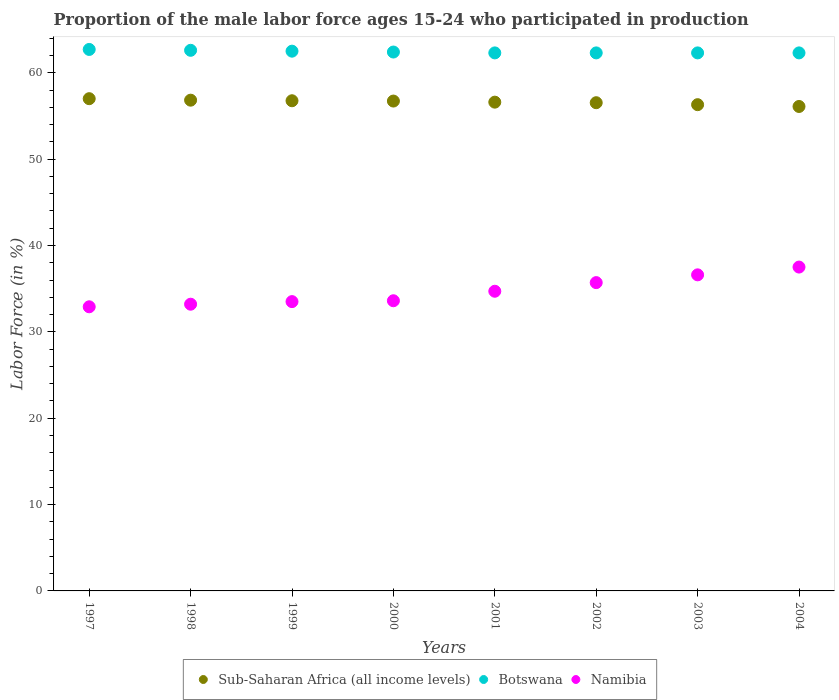What is the proportion of the male labor force who participated in production in Sub-Saharan Africa (all income levels) in 1999?
Ensure brevity in your answer.  56.76. Across all years, what is the maximum proportion of the male labor force who participated in production in Namibia?
Keep it short and to the point. 37.5. Across all years, what is the minimum proportion of the male labor force who participated in production in Botswana?
Make the answer very short. 62.3. In which year was the proportion of the male labor force who participated in production in Namibia maximum?
Make the answer very short. 2004. In which year was the proportion of the male labor force who participated in production in Botswana minimum?
Your answer should be compact. 2001. What is the total proportion of the male labor force who participated in production in Namibia in the graph?
Make the answer very short. 277.7. What is the difference between the proportion of the male labor force who participated in production in Botswana in 1998 and that in 2001?
Make the answer very short. 0.3. What is the difference between the proportion of the male labor force who participated in production in Sub-Saharan Africa (all income levels) in 2003 and the proportion of the male labor force who participated in production in Namibia in 1997?
Provide a succinct answer. 23.4. What is the average proportion of the male labor force who participated in production in Botswana per year?
Your answer should be compact. 62.42. In the year 2000, what is the difference between the proportion of the male labor force who participated in production in Sub-Saharan Africa (all income levels) and proportion of the male labor force who participated in production in Namibia?
Offer a terse response. 23.12. In how many years, is the proportion of the male labor force who participated in production in Namibia greater than 32 %?
Offer a terse response. 8. What is the ratio of the proportion of the male labor force who participated in production in Botswana in 1997 to that in 1999?
Offer a terse response. 1. What is the difference between the highest and the second highest proportion of the male labor force who participated in production in Botswana?
Make the answer very short. 0.1. What is the difference between the highest and the lowest proportion of the male labor force who participated in production in Namibia?
Offer a terse response. 4.6. In how many years, is the proportion of the male labor force who participated in production in Namibia greater than the average proportion of the male labor force who participated in production in Namibia taken over all years?
Your answer should be compact. 3. Is it the case that in every year, the sum of the proportion of the male labor force who participated in production in Sub-Saharan Africa (all income levels) and proportion of the male labor force who participated in production in Namibia  is greater than the proportion of the male labor force who participated in production in Botswana?
Your answer should be compact. Yes. Is the proportion of the male labor force who participated in production in Botswana strictly less than the proportion of the male labor force who participated in production in Sub-Saharan Africa (all income levels) over the years?
Your answer should be very brief. No. How many years are there in the graph?
Keep it short and to the point. 8. What is the difference between two consecutive major ticks on the Y-axis?
Offer a very short reply. 10. Does the graph contain any zero values?
Your response must be concise. No. Does the graph contain grids?
Offer a very short reply. No. Where does the legend appear in the graph?
Make the answer very short. Bottom center. How are the legend labels stacked?
Your answer should be compact. Horizontal. What is the title of the graph?
Offer a terse response. Proportion of the male labor force ages 15-24 who participated in production. What is the label or title of the Y-axis?
Provide a succinct answer. Labor Force (in %). What is the Labor Force (in %) of Sub-Saharan Africa (all income levels) in 1997?
Make the answer very short. 57. What is the Labor Force (in %) in Botswana in 1997?
Your answer should be very brief. 62.7. What is the Labor Force (in %) of Namibia in 1997?
Keep it short and to the point. 32.9. What is the Labor Force (in %) in Sub-Saharan Africa (all income levels) in 1998?
Make the answer very short. 56.83. What is the Labor Force (in %) in Botswana in 1998?
Offer a terse response. 62.6. What is the Labor Force (in %) in Namibia in 1998?
Your response must be concise. 33.2. What is the Labor Force (in %) in Sub-Saharan Africa (all income levels) in 1999?
Give a very brief answer. 56.76. What is the Labor Force (in %) of Botswana in 1999?
Your response must be concise. 62.5. What is the Labor Force (in %) of Namibia in 1999?
Offer a very short reply. 33.5. What is the Labor Force (in %) in Sub-Saharan Africa (all income levels) in 2000?
Keep it short and to the point. 56.72. What is the Labor Force (in %) of Botswana in 2000?
Provide a succinct answer. 62.4. What is the Labor Force (in %) of Namibia in 2000?
Make the answer very short. 33.6. What is the Labor Force (in %) in Sub-Saharan Africa (all income levels) in 2001?
Your answer should be very brief. 56.6. What is the Labor Force (in %) in Botswana in 2001?
Your response must be concise. 62.3. What is the Labor Force (in %) of Namibia in 2001?
Make the answer very short. 34.7. What is the Labor Force (in %) of Sub-Saharan Africa (all income levels) in 2002?
Provide a succinct answer. 56.53. What is the Labor Force (in %) of Botswana in 2002?
Your response must be concise. 62.3. What is the Labor Force (in %) of Namibia in 2002?
Provide a short and direct response. 35.7. What is the Labor Force (in %) of Sub-Saharan Africa (all income levels) in 2003?
Give a very brief answer. 56.3. What is the Labor Force (in %) of Botswana in 2003?
Make the answer very short. 62.3. What is the Labor Force (in %) of Namibia in 2003?
Provide a short and direct response. 36.6. What is the Labor Force (in %) in Sub-Saharan Africa (all income levels) in 2004?
Ensure brevity in your answer.  56.1. What is the Labor Force (in %) of Botswana in 2004?
Make the answer very short. 62.3. What is the Labor Force (in %) of Namibia in 2004?
Offer a terse response. 37.5. Across all years, what is the maximum Labor Force (in %) in Sub-Saharan Africa (all income levels)?
Provide a short and direct response. 57. Across all years, what is the maximum Labor Force (in %) of Botswana?
Keep it short and to the point. 62.7. Across all years, what is the maximum Labor Force (in %) of Namibia?
Your answer should be very brief. 37.5. Across all years, what is the minimum Labor Force (in %) of Sub-Saharan Africa (all income levels)?
Your answer should be compact. 56.1. Across all years, what is the minimum Labor Force (in %) in Botswana?
Your answer should be compact. 62.3. Across all years, what is the minimum Labor Force (in %) of Namibia?
Your response must be concise. 32.9. What is the total Labor Force (in %) in Sub-Saharan Africa (all income levels) in the graph?
Make the answer very short. 452.83. What is the total Labor Force (in %) in Botswana in the graph?
Your answer should be very brief. 499.4. What is the total Labor Force (in %) in Namibia in the graph?
Your answer should be compact. 277.7. What is the difference between the Labor Force (in %) of Sub-Saharan Africa (all income levels) in 1997 and that in 1998?
Your response must be concise. 0.17. What is the difference between the Labor Force (in %) of Namibia in 1997 and that in 1998?
Provide a succinct answer. -0.3. What is the difference between the Labor Force (in %) in Sub-Saharan Africa (all income levels) in 1997 and that in 1999?
Provide a succinct answer. 0.24. What is the difference between the Labor Force (in %) in Botswana in 1997 and that in 1999?
Offer a terse response. 0.2. What is the difference between the Labor Force (in %) in Sub-Saharan Africa (all income levels) in 1997 and that in 2000?
Provide a succinct answer. 0.28. What is the difference between the Labor Force (in %) of Botswana in 1997 and that in 2000?
Your response must be concise. 0.3. What is the difference between the Labor Force (in %) of Sub-Saharan Africa (all income levels) in 1997 and that in 2001?
Keep it short and to the point. 0.4. What is the difference between the Labor Force (in %) in Botswana in 1997 and that in 2001?
Your response must be concise. 0.4. What is the difference between the Labor Force (in %) of Sub-Saharan Africa (all income levels) in 1997 and that in 2002?
Your answer should be compact. 0.47. What is the difference between the Labor Force (in %) of Botswana in 1997 and that in 2002?
Your answer should be very brief. 0.4. What is the difference between the Labor Force (in %) in Namibia in 1997 and that in 2002?
Provide a succinct answer. -2.8. What is the difference between the Labor Force (in %) in Sub-Saharan Africa (all income levels) in 1997 and that in 2003?
Your answer should be compact. 0.69. What is the difference between the Labor Force (in %) in Botswana in 1997 and that in 2003?
Give a very brief answer. 0.4. What is the difference between the Labor Force (in %) in Namibia in 1997 and that in 2003?
Your answer should be compact. -3.7. What is the difference between the Labor Force (in %) in Sub-Saharan Africa (all income levels) in 1997 and that in 2004?
Provide a short and direct response. 0.9. What is the difference between the Labor Force (in %) in Botswana in 1997 and that in 2004?
Your answer should be very brief. 0.4. What is the difference between the Labor Force (in %) in Namibia in 1997 and that in 2004?
Offer a very short reply. -4.6. What is the difference between the Labor Force (in %) of Sub-Saharan Africa (all income levels) in 1998 and that in 1999?
Provide a succinct answer. 0.07. What is the difference between the Labor Force (in %) of Sub-Saharan Africa (all income levels) in 1998 and that in 2000?
Keep it short and to the point. 0.1. What is the difference between the Labor Force (in %) of Namibia in 1998 and that in 2000?
Your answer should be compact. -0.4. What is the difference between the Labor Force (in %) of Sub-Saharan Africa (all income levels) in 1998 and that in 2001?
Your answer should be very brief. 0.23. What is the difference between the Labor Force (in %) of Botswana in 1998 and that in 2001?
Your answer should be compact. 0.3. What is the difference between the Labor Force (in %) of Namibia in 1998 and that in 2001?
Your response must be concise. -1.5. What is the difference between the Labor Force (in %) in Sub-Saharan Africa (all income levels) in 1998 and that in 2002?
Ensure brevity in your answer.  0.29. What is the difference between the Labor Force (in %) of Namibia in 1998 and that in 2002?
Keep it short and to the point. -2.5. What is the difference between the Labor Force (in %) of Sub-Saharan Africa (all income levels) in 1998 and that in 2003?
Give a very brief answer. 0.52. What is the difference between the Labor Force (in %) in Namibia in 1998 and that in 2003?
Offer a very short reply. -3.4. What is the difference between the Labor Force (in %) in Sub-Saharan Africa (all income levels) in 1998 and that in 2004?
Keep it short and to the point. 0.73. What is the difference between the Labor Force (in %) of Botswana in 1998 and that in 2004?
Your response must be concise. 0.3. What is the difference between the Labor Force (in %) in Namibia in 1998 and that in 2004?
Your answer should be compact. -4.3. What is the difference between the Labor Force (in %) of Sub-Saharan Africa (all income levels) in 1999 and that in 2000?
Offer a very short reply. 0.04. What is the difference between the Labor Force (in %) of Sub-Saharan Africa (all income levels) in 1999 and that in 2001?
Your answer should be very brief. 0.16. What is the difference between the Labor Force (in %) in Namibia in 1999 and that in 2001?
Your response must be concise. -1.2. What is the difference between the Labor Force (in %) of Sub-Saharan Africa (all income levels) in 1999 and that in 2002?
Give a very brief answer. 0.23. What is the difference between the Labor Force (in %) of Botswana in 1999 and that in 2002?
Your answer should be compact. 0.2. What is the difference between the Labor Force (in %) of Namibia in 1999 and that in 2002?
Your answer should be very brief. -2.2. What is the difference between the Labor Force (in %) in Sub-Saharan Africa (all income levels) in 1999 and that in 2003?
Your answer should be compact. 0.45. What is the difference between the Labor Force (in %) of Namibia in 1999 and that in 2003?
Provide a succinct answer. -3.1. What is the difference between the Labor Force (in %) of Sub-Saharan Africa (all income levels) in 1999 and that in 2004?
Provide a short and direct response. 0.66. What is the difference between the Labor Force (in %) in Botswana in 1999 and that in 2004?
Provide a succinct answer. 0.2. What is the difference between the Labor Force (in %) in Namibia in 1999 and that in 2004?
Give a very brief answer. -4. What is the difference between the Labor Force (in %) of Sub-Saharan Africa (all income levels) in 2000 and that in 2001?
Ensure brevity in your answer.  0.13. What is the difference between the Labor Force (in %) in Namibia in 2000 and that in 2001?
Your answer should be very brief. -1.1. What is the difference between the Labor Force (in %) of Sub-Saharan Africa (all income levels) in 2000 and that in 2002?
Your answer should be very brief. 0.19. What is the difference between the Labor Force (in %) in Namibia in 2000 and that in 2002?
Your answer should be compact. -2.1. What is the difference between the Labor Force (in %) in Sub-Saharan Africa (all income levels) in 2000 and that in 2003?
Offer a very short reply. 0.42. What is the difference between the Labor Force (in %) in Botswana in 2000 and that in 2003?
Provide a short and direct response. 0.1. What is the difference between the Labor Force (in %) of Namibia in 2000 and that in 2003?
Provide a succinct answer. -3. What is the difference between the Labor Force (in %) of Sub-Saharan Africa (all income levels) in 2000 and that in 2004?
Your answer should be very brief. 0.63. What is the difference between the Labor Force (in %) in Namibia in 2000 and that in 2004?
Provide a succinct answer. -3.9. What is the difference between the Labor Force (in %) of Sub-Saharan Africa (all income levels) in 2001 and that in 2002?
Make the answer very short. 0.06. What is the difference between the Labor Force (in %) in Botswana in 2001 and that in 2002?
Your answer should be very brief. 0. What is the difference between the Labor Force (in %) of Namibia in 2001 and that in 2002?
Make the answer very short. -1. What is the difference between the Labor Force (in %) in Sub-Saharan Africa (all income levels) in 2001 and that in 2003?
Your answer should be compact. 0.29. What is the difference between the Labor Force (in %) of Botswana in 2001 and that in 2003?
Offer a terse response. 0. What is the difference between the Labor Force (in %) of Namibia in 2001 and that in 2003?
Keep it short and to the point. -1.9. What is the difference between the Labor Force (in %) of Sub-Saharan Africa (all income levels) in 2001 and that in 2004?
Ensure brevity in your answer.  0.5. What is the difference between the Labor Force (in %) in Namibia in 2001 and that in 2004?
Offer a very short reply. -2.8. What is the difference between the Labor Force (in %) of Sub-Saharan Africa (all income levels) in 2002 and that in 2003?
Make the answer very short. 0.23. What is the difference between the Labor Force (in %) in Botswana in 2002 and that in 2003?
Provide a short and direct response. 0. What is the difference between the Labor Force (in %) of Sub-Saharan Africa (all income levels) in 2002 and that in 2004?
Ensure brevity in your answer.  0.44. What is the difference between the Labor Force (in %) in Sub-Saharan Africa (all income levels) in 2003 and that in 2004?
Your answer should be compact. 0.21. What is the difference between the Labor Force (in %) of Botswana in 2003 and that in 2004?
Offer a very short reply. 0. What is the difference between the Labor Force (in %) of Namibia in 2003 and that in 2004?
Ensure brevity in your answer.  -0.9. What is the difference between the Labor Force (in %) in Sub-Saharan Africa (all income levels) in 1997 and the Labor Force (in %) in Botswana in 1998?
Your answer should be very brief. -5.6. What is the difference between the Labor Force (in %) of Sub-Saharan Africa (all income levels) in 1997 and the Labor Force (in %) of Namibia in 1998?
Provide a short and direct response. 23.8. What is the difference between the Labor Force (in %) of Botswana in 1997 and the Labor Force (in %) of Namibia in 1998?
Offer a very short reply. 29.5. What is the difference between the Labor Force (in %) in Sub-Saharan Africa (all income levels) in 1997 and the Labor Force (in %) in Botswana in 1999?
Your answer should be very brief. -5.5. What is the difference between the Labor Force (in %) in Sub-Saharan Africa (all income levels) in 1997 and the Labor Force (in %) in Namibia in 1999?
Keep it short and to the point. 23.5. What is the difference between the Labor Force (in %) of Botswana in 1997 and the Labor Force (in %) of Namibia in 1999?
Offer a terse response. 29.2. What is the difference between the Labor Force (in %) of Sub-Saharan Africa (all income levels) in 1997 and the Labor Force (in %) of Botswana in 2000?
Ensure brevity in your answer.  -5.4. What is the difference between the Labor Force (in %) of Sub-Saharan Africa (all income levels) in 1997 and the Labor Force (in %) of Namibia in 2000?
Provide a short and direct response. 23.4. What is the difference between the Labor Force (in %) of Botswana in 1997 and the Labor Force (in %) of Namibia in 2000?
Your answer should be compact. 29.1. What is the difference between the Labor Force (in %) in Sub-Saharan Africa (all income levels) in 1997 and the Labor Force (in %) in Botswana in 2001?
Ensure brevity in your answer.  -5.3. What is the difference between the Labor Force (in %) in Sub-Saharan Africa (all income levels) in 1997 and the Labor Force (in %) in Namibia in 2001?
Offer a terse response. 22.3. What is the difference between the Labor Force (in %) of Botswana in 1997 and the Labor Force (in %) of Namibia in 2001?
Provide a short and direct response. 28. What is the difference between the Labor Force (in %) in Sub-Saharan Africa (all income levels) in 1997 and the Labor Force (in %) in Botswana in 2002?
Ensure brevity in your answer.  -5.3. What is the difference between the Labor Force (in %) of Sub-Saharan Africa (all income levels) in 1997 and the Labor Force (in %) of Namibia in 2002?
Keep it short and to the point. 21.3. What is the difference between the Labor Force (in %) in Botswana in 1997 and the Labor Force (in %) in Namibia in 2002?
Make the answer very short. 27. What is the difference between the Labor Force (in %) of Sub-Saharan Africa (all income levels) in 1997 and the Labor Force (in %) of Botswana in 2003?
Ensure brevity in your answer.  -5.3. What is the difference between the Labor Force (in %) in Sub-Saharan Africa (all income levels) in 1997 and the Labor Force (in %) in Namibia in 2003?
Keep it short and to the point. 20.4. What is the difference between the Labor Force (in %) of Botswana in 1997 and the Labor Force (in %) of Namibia in 2003?
Offer a very short reply. 26.1. What is the difference between the Labor Force (in %) of Sub-Saharan Africa (all income levels) in 1997 and the Labor Force (in %) of Botswana in 2004?
Offer a terse response. -5.3. What is the difference between the Labor Force (in %) of Sub-Saharan Africa (all income levels) in 1997 and the Labor Force (in %) of Namibia in 2004?
Give a very brief answer. 19.5. What is the difference between the Labor Force (in %) in Botswana in 1997 and the Labor Force (in %) in Namibia in 2004?
Offer a very short reply. 25.2. What is the difference between the Labor Force (in %) of Sub-Saharan Africa (all income levels) in 1998 and the Labor Force (in %) of Botswana in 1999?
Your response must be concise. -5.67. What is the difference between the Labor Force (in %) in Sub-Saharan Africa (all income levels) in 1998 and the Labor Force (in %) in Namibia in 1999?
Offer a terse response. 23.33. What is the difference between the Labor Force (in %) of Botswana in 1998 and the Labor Force (in %) of Namibia in 1999?
Offer a very short reply. 29.1. What is the difference between the Labor Force (in %) of Sub-Saharan Africa (all income levels) in 1998 and the Labor Force (in %) of Botswana in 2000?
Provide a short and direct response. -5.57. What is the difference between the Labor Force (in %) of Sub-Saharan Africa (all income levels) in 1998 and the Labor Force (in %) of Namibia in 2000?
Give a very brief answer. 23.23. What is the difference between the Labor Force (in %) in Botswana in 1998 and the Labor Force (in %) in Namibia in 2000?
Provide a succinct answer. 29. What is the difference between the Labor Force (in %) of Sub-Saharan Africa (all income levels) in 1998 and the Labor Force (in %) of Botswana in 2001?
Provide a short and direct response. -5.47. What is the difference between the Labor Force (in %) of Sub-Saharan Africa (all income levels) in 1998 and the Labor Force (in %) of Namibia in 2001?
Give a very brief answer. 22.13. What is the difference between the Labor Force (in %) in Botswana in 1998 and the Labor Force (in %) in Namibia in 2001?
Provide a succinct answer. 27.9. What is the difference between the Labor Force (in %) in Sub-Saharan Africa (all income levels) in 1998 and the Labor Force (in %) in Botswana in 2002?
Offer a terse response. -5.47. What is the difference between the Labor Force (in %) of Sub-Saharan Africa (all income levels) in 1998 and the Labor Force (in %) of Namibia in 2002?
Provide a short and direct response. 21.13. What is the difference between the Labor Force (in %) of Botswana in 1998 and the Labor Force (in %) of Namibia in 2002?
Make the answer very short. 26.9. What is the difference between the Labor Force (in %) in Sub-Saharan Africa (all income levels) in 1998 and the Labor Force (in %) in Botswana in 2003?
Provide a succinct answer. -5.47. What is the difference between the Labor Force (in %) in Sub-Saharan Africa (all income levels) in 1998 and the Labor Force (in %) in Namibia in 2003?
Make the answer very short. 20.23. What is the difference between the Labor Force (in %) of Sub-Saharan Africa (all income levels) in 1998 and the Labor Force (in %) of Botswana in 2004?
Your answer should be compact. -5.47. What is the difference between the Labor Force (in %) of Sub-Saharan Africa (all income levels) in 1998 and the Labor Force (in %) of Namibia in 2004?
Offer a terse response. 19.33. What is the difference between the Labor Force (in %) in Botswana in 1998 and the Labor Force (in %) in Namibia in 2004?
Provide a succinct answer. 25.1. What is the difference between the Labor Force (in %) in Sub-Saharan Africa (all income levels) in 1999 and the Labor Force (in %) in Botswana in 2000?
Your answer should be very brief. -5.64. What is the difference between the Labor Force (in %) of Sub-Saharan Africa (all income levels) in 1999 and the Labor Force (in %) of Namibia in 2000?
Your answer should be very brief. 23.16. What is the difference between the Labor Force (in %) in Botswana in 1999 and the Labor Force (in %) in Namibia in 2000?
Offer a terse response. 28.9. What is the difference between the Labor Force (in %) in Sub-Saharan Africa (all income levels) in 1999 and the Labor Force (in %) in Botswana in 2001?
Offer a terse response. -5.54. What is the difference between the Labor Force (in %) of Sub-Saharan Africa (all income levels) in 1999 and the Labor Force (in %) of Namibia in 2001?
Provide a short and direct response. 22.06. What is the difference between the Labor Force (in %) of Botswana in 1999 and the Labor Force (in %) of Namibia in 2001?
Provide a succinct answer. 27.8. What is the difference between the Labor Force (in %) in Sub-Saharan Africa (all income levels) in 1999 and the Labor Force (in %) in Botswana in 2002?
Your answer should be very brief. -5.54. What is the difference between the Labor Force (in %) in Sub-Saharan Africa (all income levels) in 1999 and the Labor Force (in %) in Namibia in 2002?
Your answer should be compact. 21.06. What is the difference between the Labor Force (in %) in Botswana in 1999 and the Labor Force (in %) in Namibia in 2002?
Make the answer very short. 26.8. What is the difference between the Labor Force (in %) of Sub-Saharan Africa (all income levels) in 1999 and the Labor Force (in %) of Botswana in 2003?
Provide a succinct answer. -5.54. What is the difference between the Labor Force (in %) of Sub-Saharan Africa (all income levels) in 1999 and the Labor Force (in %) of Namibia in 2003?
Your answer should be very brief. 20.16. What is the difference between the Labor Force (in %) of Botswana in 1999 and the Labor Force (in %) of Namibia in 2003?
Provide a succinct answer. 25.9. What is the difference between the Labor Force (in %) in Sub-Saharan Africa (all income levels) in 1999 and the Labor Force (in %) in Botswana in 2004?
Your answer should be very brief. -5.54. What is the difference between the Labor Force (in %) of Sub-Saharan Africa (all income levels) in 1999 and the Labor Force (in %) of Namibia in 2004?
Offer a terse response. 19.26. What is the difference between the Labor Force (in %) of Botswana in 1999 and the Labor Force (in %) of Namibia in 2004?
Make the answer very short. 25. What is the difference between the Labor Force (in %) of Sub-Saharan Africa (all income levels) in 2000 and the Labor Force (in %) of Botswana in 2001?
Make the answer very short. -5.58. What is the difference between the Labor Force (in %) of Sub-Saharan Africa (all income levels) in 2000 and the Labor Force (in %) of Namibia in 2001?
Ensure brevity in your answer.  22.02. What is the difference between the Labor Force (in %) of Botswana in 2000 and the Labor Force (in %) of Namibia in 2001?
Offer a terse response. 27.7. What is the difference between the Labor Force (in %) of Sub-Saharan Africa (all income levels) in 2000 and the Labor Force (in %) of Botswana in 2002?
Give a very brief answer. -5.58. What is the difference between the Labor Force (in %) in Sub-Saharan Africa (all income levels) in 2000 and the Labor Force (in %) in Namibia in 2002?
Give a very brief answer. 21.02. What is the difference between the Labor Force (in %) of Botswana in 2000 and the Labor Force (in %) of Namibia in 2002?
Keep it short and to the point. 26.7. What is the difference between the Labor Force (in %) in Sub-Saharan Africa (all income levels) in 2000 and the Labor Force (in %) in Botswana in 2003?
Give a very brief answer. -5.58. What is the difference between the Labor Force (in %) in Sub-Saharan Africa (all income levels) in 2000 and the Labor Force (in %) in Namibia in 2003?
Your answer should be compact. 20.12. What is the difference between the Labor Force (in %) in Botswana in 2000 and the Labor Force (in %) in Namibia in 2003?
Give a very brief answer. 25.8. What is the difference between the Labor Force (in %) in Sub-Saharan Africa (all income levels) in 2000 and the Labor Force (in %) in Botswana in 2004?
Offer a very short reply. -5.58. What is the difference between the Labor Force (in %) in Sub-Saharan Africa (all income levels) in 2000 and the Labor Force (in %) in Namibia in 2004?
Make the answer very short. 19.22. What is the difference between the Labor Force (in %) in Botswana in 2000 and the Labor Force (in %) in Namibia in 2004?
Provide a succinct answer. 24.9. What is the difference between the Labor Force (in %) of Sub-Saharan Africa (all income levels) in 2001 and the Labor Force (in %) of Botswana in 2002?
Your response must be concise. -5.7. What is the difference between the Labor Force (in %) of Sub-Saharan Africa (all income levels) in 2001 and the Labor Force (in %) of Namibia in 2002?
Offer a terse response. 20.9. What is the difference between the Labor Force (in %) in Botswana in 2001 and the Labor Force (in %) in Namibia in 2002?
Provide a short and direct response. 26.6. What is the difference between the Labor Force (in %) in Sub-Saharan Africa (all income levels) in 2001 and the Labor Force (in %) in Botswana in 2003?
Provide a short and direct response. -5.7. What is the difference between the Labor Force (in %) of Sub-Saharan Africa (all income levels) in 2001 and the Labor Force (in %) of Namibia in 2003?
Give a very brief answer. 20. What is the difference between the Labor Force (in %) of Botswana in 2001 and the Labor Force (in %) of Namibia in 2003?
Your response must be concise. 25.7. What is the difference between the Labor Force (in %) of Sub-Saharan Africa (all income levels) in 2001 and the Labor Force (in %) of Botswana in 2004?
Your answer should be very brief. -5.7. What is the difference between the Labor Force (in %) in Sub-Saharan Africa (all income levels) in 2001 and the Labor Force (in %) in Namibia in 2004?
Give a very brief answer. 19.1. What is the difference between the Labor Force (in %) of Botswana in 2001 and the Labor Force (in %) of Namibia in 2004?
Give a very brief answer. 24.8. What is the difference between the Labor Force (in %) in Sub-Saharan Africa (all income levels) in 2002 and the Labor Force (in %) in Botswana in 2003?
Ensure brevity in your answer.  -5.77. What is the difference between the Labor Force (in %) of Sub-Saharan Africa (all income levels) in 2002 and the Labor Force (in %) of Namibia in 2003?
Provide a short and direct response. 19.93. What is the difference between the Labor Force (in %) of Botswana in 2002 and the Labor Force (in %) of Namibia in 2003?
Provide a short and direct response. 25.7. What is the difference between the Labor Force (in %) of Sub-Saharan Africa (all income levels) in 2002 and the Labor Force (in %) of Botswana in 2004?
Offer a very short reply. -5.77. What is the difference between the Labor Force (in %) in Sub-Saharan Africa (all income levels) in 2002 and the Labor Force (in %) in Namibia in 2004?
Your response must be concise. 19.03. What is the difference between the Labor Force (in %) of Botswana in 2002 and the Labor Force (in %) of Namibia in 2004?
Give a very brief answer. 24.8. What is the difference between the Labor Force (in %) of Sub-Saharan Africa (all income levels) in 2003 and the Labor Force (in %) of Botswana in 2004?
Offer a very short reply. -6. What is the difference between the Labor Force (in %) of Sub-Saharan Africa (all income levels) in 2003 and the Labor Force (in %) of Namibia in 2004?
Give a very brief answer. 18.8. What is the difference between the Labor Force (in %) of Botswana in 2003 and the Labor Force (in %) of Namibia in 2004?
Provide a short and direct response. 24.8. What is the average Labor Force (in %) in Sub-Saharan Africa (all income levels) per year?
Keep it short and to the point. 56.6. What is the average Labor Force (in %) of Botswana per year?
Your response must be concise. 62.42. What is the average Labor Force (in %) in Namibia per year?
Ensure brevity in your answer.  34.71. In the year 1997, what is the difference between the Labor Force (in %) of Sub-Saharan Africa (all income levels) and Labor Force (in %) of Botswana?
Provide a short and direct response. -5.7. In the year 1997, what is the difference between the Labor Force (in %) of Sub-Saharan Africa (all income levels) and Labor Force (in %) of Namibia?
Your answer should be compact. 24.1. In the year 1997, what is the difference between the Labor Force (in %) in Botswana and Labor Force (in %) in Namibia?
Ensure brevity in your answer.  29.8. In the year 1998, what is the difference between the Labor Force (in %) of Sub-Saharan Africa (all income levels) and Labor Force (in %) of Botswana?
Your answer should be compact. -5.77. In the year 1998, what is the difference between the Labor Force (in %) of Sub-Saharan Africa (all income levels) and Labor Force (in %) of Namibia?
Your response must be concise. 23.63. In the year 1998, what is the difference between the Labor Force (in %) of Botswana and Labor Force (in %) of Namibia?
Your response must be concise. 29.4. In the year 1999, what is the difference between the Labor Force (in %) of Sub-Saharan Africa (all income levels) and Labor Force (in %) of Botswana?
Offer a very short reply. -5.74. In the year 1999, what is the difference between the Labor Force (in %) in Sub-Saharan Africa (all income levels) and Labor Force (in %) in Namibia?
Give a very brief answer. 23.26. In the year 2000, what is the difference between the Labor Force (in %) in Sub-Saharan Africa (all income levels) and Labor Force (in %) in Botswana?
Ensure brevity in your answer.  -5.68. In the year 2000, what is the difference between the Labor Force (in %) of Sub-Saharan Africa (all income levels) and Labor Force (in %) of Namibia?
Ensure brevity in your answer.  23.12. In the year 2000, what is the difference between the Labor Force (in %) of Botswana and Labor Force (in %) of Namibia?
Ensure brevity in your answer.  28.8. In the year 2001, what is the difference between the Labor Force (in %) of Sub-Saharan Africa (all income levels) and Labor Force (in %) of Botswana?
Your answer should be very brief. -5.7. In the year 2001, what is the difference between the Labor Force (in %) in Sub-Saharan Africa (all income levels) and Labor Force (in %) in Namibia?
Offer a terse response. 21.9. In the year 2001, what is the difference between the Labor Force (in %) in Botswana and Labor Force (in %) in Namibia?
Make the answer very short. 27.6. In the year 2002, what is the difference between the Labor Force (in %) in Sub-Saharan Africa (all income levels) and Labor Force (in %) in Botswana?
Give a very brief answer. -5.77. In the year 2002, what is the difference between the Labor Force (in %) in Sub-Saharan Africa (all income levels) and Labor Force (in %) in Namibia?
Your answer should be compact. 20.83. In the year 2002, what is the difference between the Labor Force (in %) in Botswana and Labor Force (in %) in Namibia?
Your answer should be compact. 26.6. In the year 2003, what is the difference between the Labor Force (in %) in Sub-Saharan Africa (all income levels) and Labor Force (in %) in Botswana?
Provide a short and direct response. -6. In the year 2003, what is the difference between the Labor Force (in %) in Sub-Saharan Africa (all income levels) and Labor Force (in %) in Namibia?
Provide a short and direct response. 19.7. In the year 2003, what is the difference between the Labor Force (in %) of Botswana and Labor Force (in %) of Namibia?
Your answer should be compact. 25.7. In the year 2004, what is the difference between the Labor Force (in %) of Sub-Saharan Africa (all income levels) and Labor Force (in %) of Botswana?
Ensure brevity in your answer.  -6.2. In the year 2004, what is the difference between the Labor Force (in %) in Sub-Saharan Africa (all income levels) and Labor Force (in %) in Namibia?
Offer a very short reply. 18.6. In the year 2004, what is the difference between the Labor Force (in %) of Botswana and Labor Force (in %) of Namibia?
Give a very brief answer. 24.8. What is the ratio of the Labor Force (in %) in Sub-Saharan Africa (all income levels) in 1997 to that in 1998?
Provide a succinct answer. 1. What is the ratio of the Labor Force (in %) of Namibia in 1997 to that in 1998?
Ensure brevity in your answer.  0.99. What is the ratio of the Labor Force (in %) in Namibia in 1997 to that in 1999?
Provide a short and direct response. 0.98. What is the ratio of the Labor Force (in %) of Namibia in 1997 to that in 2000?
Ensure brevity in your answer.  0.98. What is the ratio of the Labor Force (in %) in Sub-Saharan Africa (all income levels) in 1997 to that in 2001?
Your response must be concise. 1.01. What is the ratio of the Labor Force (in %) of Botswana in 1997 to that in 2001?
Your answer should be very brief. 1.01. What is the ratio of the Labor Force (in %) of Namibia in 1997 to that in 2001?
Offer a terse response. 0.95. What is the ratio of the Labor Force (in %) in Sub-Saharan Africa (all income levels) in 1997 to that in 2002?
Offer a terse response. 1.01. What is the ratio of the Labor Force (in %) of Botswana in 1997 to that in 2002?
Make the answer very short. 1.01. What is the ratio of the Labor Force (in %) of Namibia in 1997 to that in 2002?
Ensure brevity in your answer.  0.92. What is the ratio of the Labor Force (in %) in Sub-Saharan Africa (all income levels) in 1997 to that in 2003?
Offer a very short reply. 1.01. What is the ratio of the Labor Force (in %) in Botswana in 1997 to that in 2003?
Keep it short and to the point. 1.01. What is the ratio of the Labor Force (in %) of Namibia in 1997 to that in 2003?
Provide a succinct answer. 0.9. What is the ratio of the Labor Force (in %) of Sub-Saharan Africa (all income levels) in 1997 to that in 2004?
Your answer should be compact. 1.02. What is the ratio of the Labor Force (in %) in Botswana in 1997 to that in 2004?
Keep it short and to the point. 1.01. What is the ratio of the Labor Force (in %) of Namibia in 1997 to that in 2004?
Your answer should be very brief. 0.88. What is the ratio of the Labor Force (in %) of Sub-Saharan Africa (all income levels) in 1998 to that in 1999?
Provide a short and direct response. 1. What is the ratio of the Labor Force (in %) in Botswana in 1998 to that in 1999?
Your answer should be compact. 1. What is the ratio of the Labor Force (in %) in Namibia in 1998 to that in 1999?
Make the answer very short. 0.99. What is the ratio of the Labor Force (in %) in Namibia in 1998 to that in 2000?
Your answer should be very brief. 0.99. What is the ratio of the Labor Force (in %) in Sub-Saharan Africa (all income levels) in 1998 to that in 2001?
Your answer should be compact. 1. What is the ratio of the Labor Force (in %) in Namibia in 1998 to that in 2001?
Give a very brief answer. 0.96. What is the ratio of the Labor Force (in %) of Sub-Saharan Africa (all income levels) in 1998 to that in 2002?
Your response must be concise. 1.01. What is the ratio of the Labor Force (in %) in Botswana in 1998 to that in 2002?
Provide a succinct answer. 1. What is the ratio of the Labor Force (in %) of Namibia in 1998 to that in 2002?
Provide a succinct answer. 0.93. What is the ratio of the Labor Force (in %) in Sub-Saharan Africa (all income levels) in 1998 to that in 2003?
Your answer should be compact. 1.01. What is the ratio of the Labor Force (in %) in Namibia in 1998 to that in 2003?
Offer a very short reply. 0.91. What is the ratio of the Labor Force (in %) of Sub-Saharan Africa (all income levels) in 1998 to that in 2004?
Provide a short and direct response. 1.01. What is the ratio of the Labor Force (in %) in Botswana in 1998 to that in 2004?
Your answer should be compact. 1. What is the ratio of the Labor Force (in %) of Namibia in 1998 to that in 2004?
Offer a very short reply. 0.89. What is the ratio of the Labor Force (in %) of Sub-Saharan Africa (all income levels) in 1999 to that in 2000?
Provide a short and direct response. 1. What is the ratio of the Labor Force (in %) of Botswana in 1999 to that in 2000?
Provide a succinct answer. 1. What is the ratio of the Labor Force (in %) of Sub-Saharan Africa (all income levels) in 1999 to that in 2001?
Your answer should be compact. 1. What is the ratio of the Labor Force (in %) in Namibia in 1999 to that in 2001?
Offer a very short reply. 0.97. What is the ratio of the Labor Force (in %) in Namibia in 1999 to that in 2002?
Make the answer very short. 0.94. What is the ratio of the Labor Force (in %) of Botswana in 1999 to that in 2003?
Ensure brevity in your answer.  1. What is the ratio of the Labor Force (in %) of Namibia in 1999 to that in 2003?
Provide a succinct answer. 0.92. What is the ratio of the Labor Force (in %) of Sub-Saharan Africa (all income levels) in 1999 to that in 2004?
Make the answer very short. 1.01. What is the ratio of the Labor Force (in %) in Namibia in 1999 to that in 2004?
Offer a terse response. 0.89. What is the ratio of the Labor Force (in %) in Namibia in 2000 to that in 2001?
Provide a short and direct response. 0.97. What is the ratio of the Labor Force (in %) in Sub-Saharan Africa (all income levels) in 2000 to that in 2002?
Offer a very short reply. 1. What is the ratio of the Labor Force (in %) in Sub-Saharan Africa (all income levels) in 2000 to that in 2003?
Give a very brief answer. 1.01. What is the ratio of the Labor Force (in %) in Botswana in 2000 to that in 2003?
Your answer should be very brief. 1. What is the ratio of the Labor Force (in %) in Namibia in 2000 to that in 2003?
Ensure brevity in your answer.  0.92. What is the ratio of the Labor Force (in %) of Sub-Saharan Africa (all income levels) in 2000 to that in 2004?
Offer a terse response. 1.01. What is the ratio of the Labor Force (in %) in Botswana in 2000 to that in 2004?
Give a very brief answer. 1. What is the ratio of the Labor Force (in %) in Namibia in 2000 to that in 2004?
Provide a succinct answer. 0.9. What is the ratio of the Labor Force (in %) of Sub-Saharan Africa (all income levels) in 2001 to that in 2002?
Your answer should be compact. 1. What is the ratio of the Labor Force (in %) in Botswana in 2001 to that in 2002?
Your answer should be compact. 1. What is the ratio of the Labor Force (in %) in Namibia in 2001 to that in 2002?
Offer a very short reply. 0.97. What is the ratio of the Labor Force (in %) in Sub-Saharan Africa (all income levels) in 2001 to that in 2003?
Give a very brief answer. 1.01. What is the ratio of the Labor Force (in %) in Botswana in 2001 to that in 2003?
Give a very brief answer. 1. What is the ratio of the Labor Force (in %) in Namibia in 2001 to that in 2003?
Offer a terse response. 0.95. What is the ratio of the Labor Force (in %) in Sub-Saharan Africa (all income levels) in 2001 to that in 2004?
Your answer should be compact. 1.01. What is the ratio of the Labor Force (in %) in Namibia in 2001 to that in 2004?
Provide a succinct answer. 0.93. What is the ratio of the Labor Force (in %) of Namibia in 2002 to that in 2003?
Provide a succinct answer. 0.98. What is the ratio of the Labor Force (in %) of Namibia in 2002 to that in 2004?
Your response must be concise. 0.95. What is the ratio of the Labor Force (in %) of Sub-Saharan Africa (all income levels) in 2003 to that in 2004?
Provide a succinct answer. 1. What is the ratio of the Labor Force (in %) of Namibia in 2003 to that in 2004?
Provide a short and direct response. 0.98. What is the difference between the highest and the second highest Labor Force (in %) of Sub-Saharan Africa (all income levels)?
Provide a succinct answer. 0.17. What is the difference between the highest and the second highest Labor Force (in %) in Botswana?
Your answer should be very brief. 0.1. What is the difference between the highest and the lowest Labor Force (in %) of Sub-Saharan Africa (all income levels)?
Ensure brevity in your answer.  0.9. What is the difference between the highest and the lowest Labor Force (in %) in Namibia?
Give a very brief answer. 4.6. 